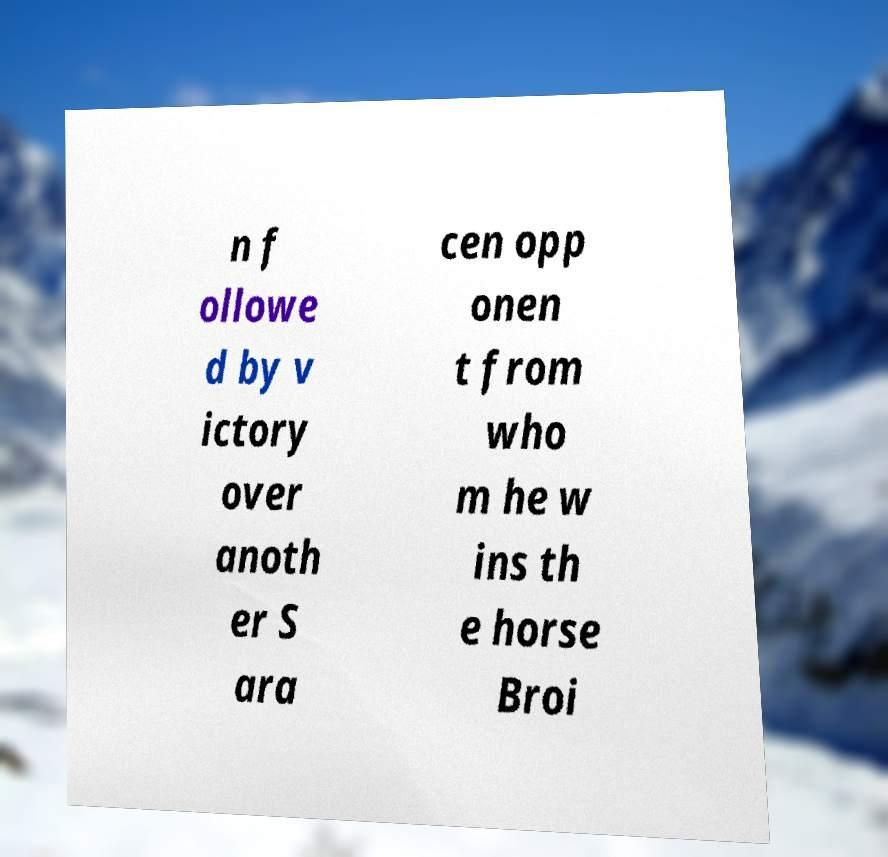I need the written content from this picture converted into text. Can you do that? n f ollowe d by v ictory over anoth er S ara cen opp onen t from who m he w ins th e horse Broi 